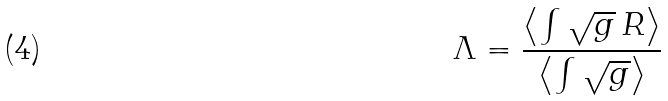<formula> <loc_0><loc_0><loc_500><loc_500>\Lambda = \frac { \left < \int \sqrt { g } \, R \right > } { \left < \int \sqrt { g } \right > }</formula> 